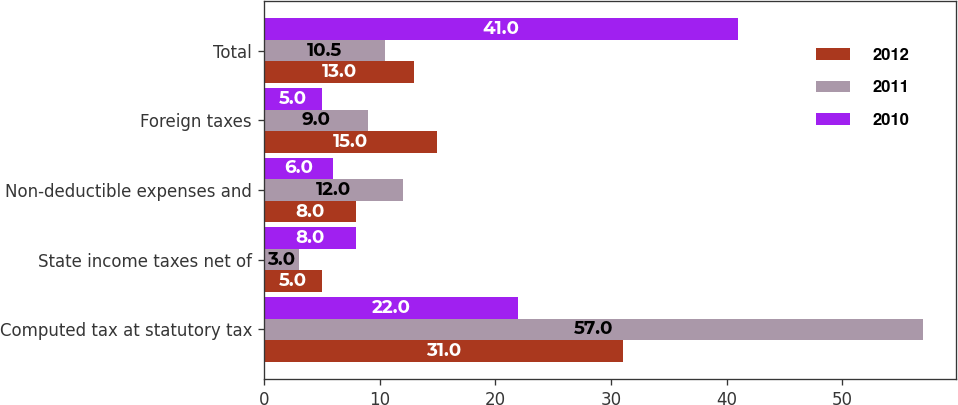Convert chart. <chart><loc_0><loc_0><loc_500><loc_500><stacked_bar_chart><ecel><fcel>Computed tax at statutory tax<fcel>State income taxes net of<fcel>Non-deductible expenses and<fcel>Foreign taxes<fcel>Total<nl><fcel>2012<fcel>31<fcel>5<fcel>8<fcel>15<fcel>13<nl><fcel>2011<fcel>57<fcel>3<fcel>12<fcel>9<fcel>10.5<nl><fcel>2010<fcel>22<fcel>8<fcel>6<fcel>5<fcel>41<nl></chart> 